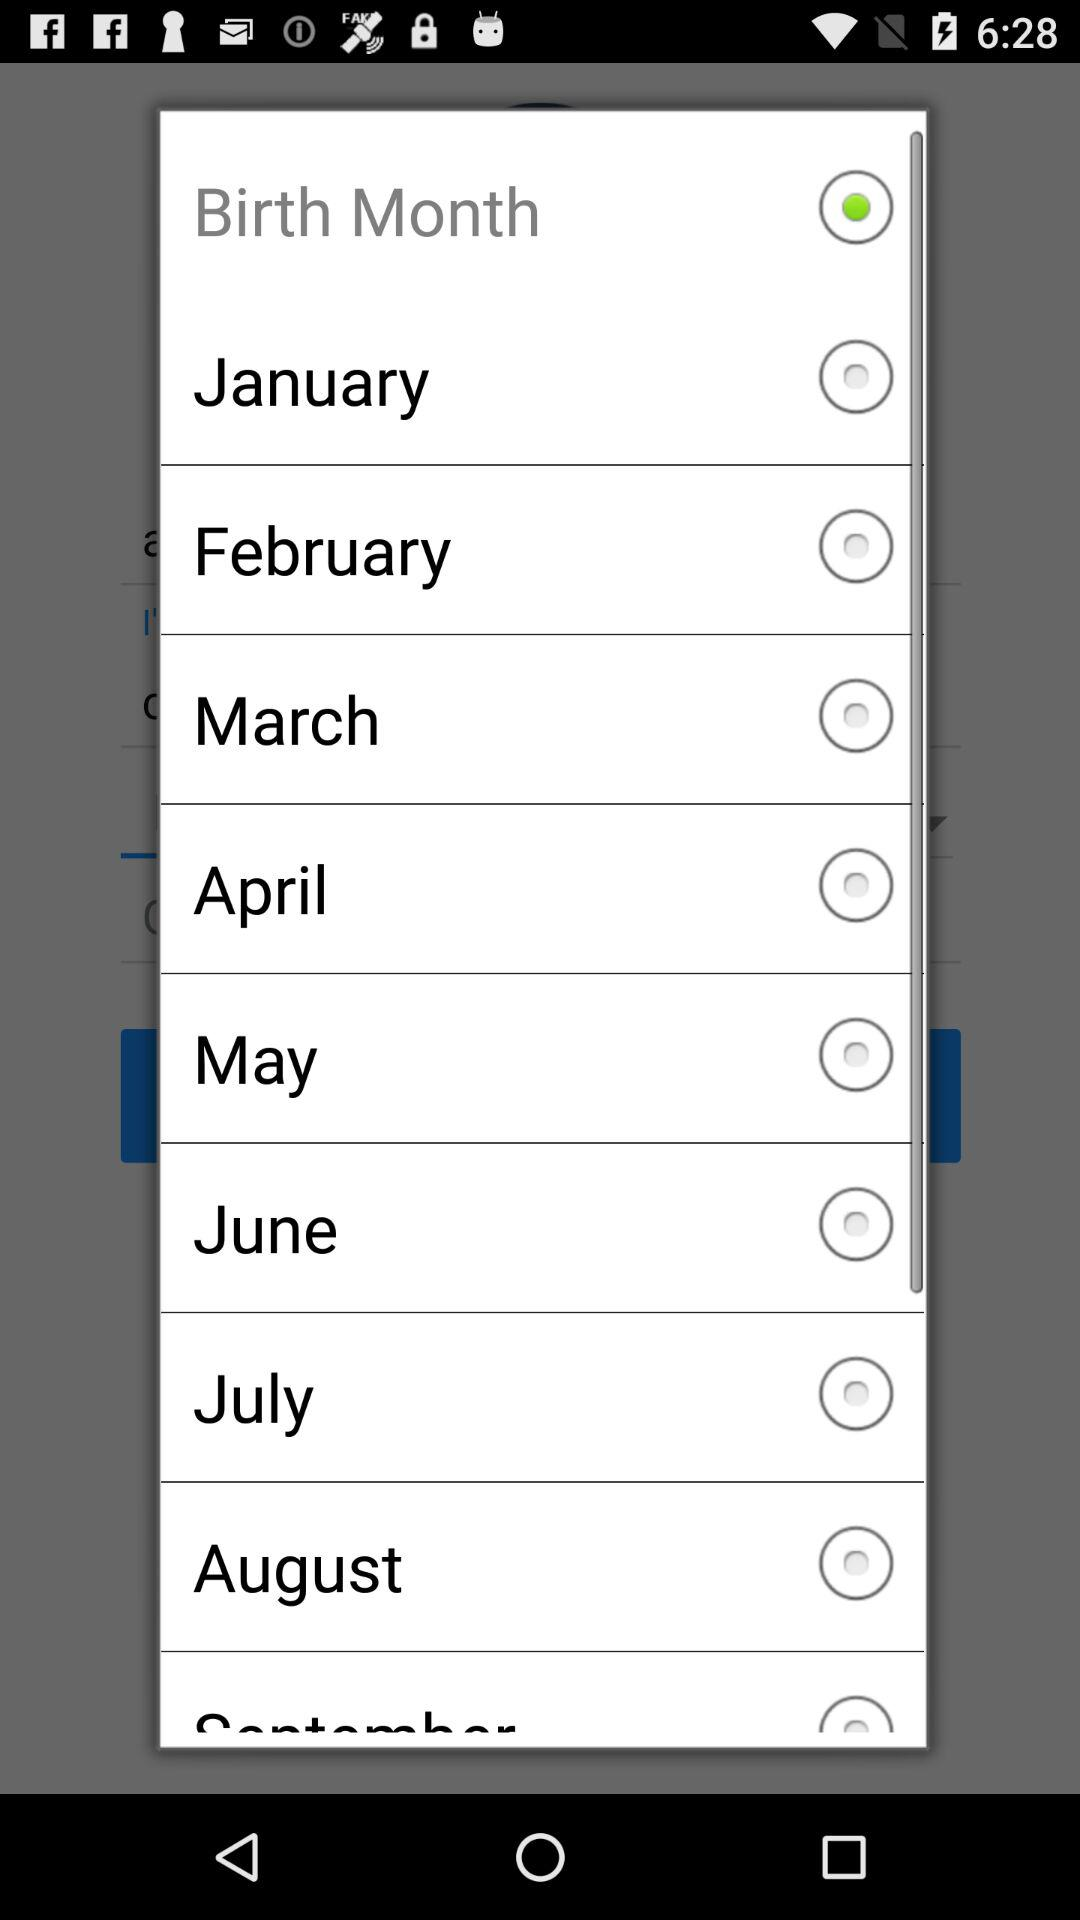What is the selected option? The selected option is "Birth Month". 